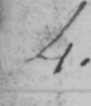Please provide the text content of this handwritten line. 4 . 